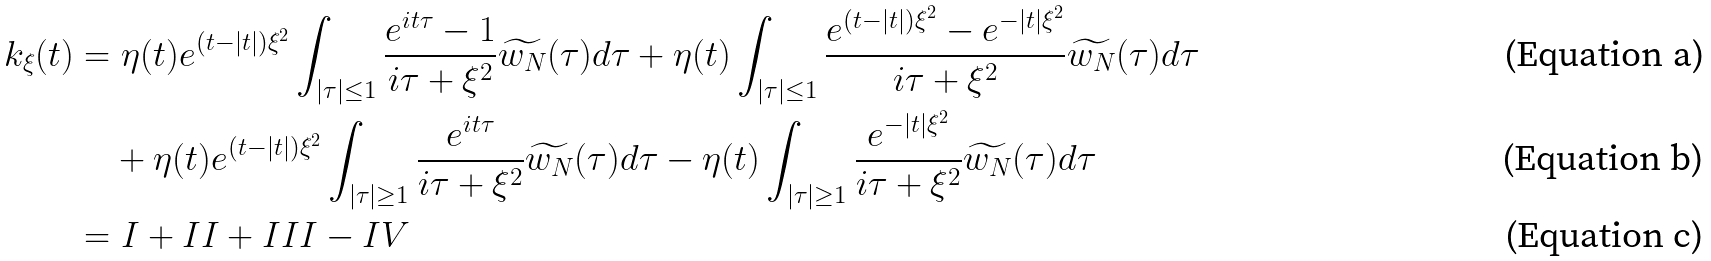Convert formula to latex. <formula><loc_0><loc_0><loc_500><loc_500>k _ { \xi } ( t ) & = \eta ( t ) e ^ { ( t - | t | ) \xi ^ { 2 } } \int _ { | \tau | \leq 1 } \frac { e ^ { i t \tau } - 1 } { i \tau + \xi ^ { 2 } } \widetilde { w _ { N } } ( \tau ) d \tau + \eta ( t ) \int _ { | \tau | \leq 1 } \frac { e ^ { ( t - | t | ) \xi ^ { 2 } } - e ^ { - | t | \xi ^ { 2 } } } { i \tau + \xi ^ { 2 } } \widetilde { w _ { N } } ( \tau ) d \tau \\ & \quad + \eta ( t ) e ^ { ( t - | t | ) \xi ^ { 2 } } \int _ { | \tau | \geq 1 } \frac { e ^ { i t \tau } } { i \tau + \xi ^ { 2 } } \widetilde { w _ { N } } ( \tau ) d \tau - \eta ( t ) \int _ { | \tau | \geq 1 } \frac { e ^ { - | t | \xi ^ { 2 } } } { i \tau + \xi ^ { 2 } } \widetilde { w _ { N } } ( \tau ) d \tau \\ & = I + I I + I I I - I V</formula> 